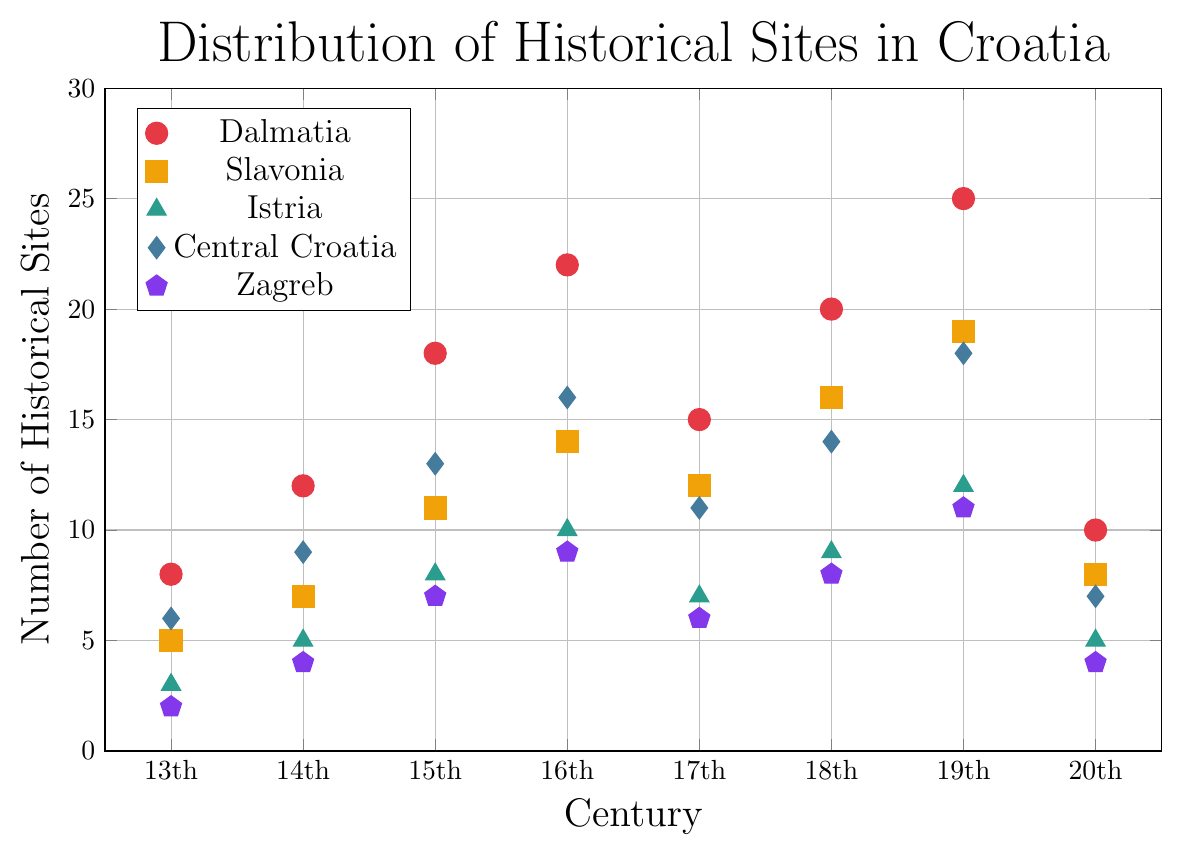Which region has the highest number of historical sites in the 16th century? Locate the data points for the 16th century and compare the values for each region. Dalmatia has 22 sites, which is the highest.
Answer: Dalmatia Which century had the highest average number of historical sites across all regions? First, calculate the average number of sites for each century by summing the number of sites for all regions within that century and then dividing by 5 (since there are five regions). Compare these averages. The 19th century has the highest average.
Answer: 19th century How did the number of historical sites in Zagreb change from the 13th century to the 19th century? Observe the values for Zagreb in both the 13th and 19th centuries. The number of sites increased from 2 in the 13th century to 11 in the 19th century.
Answer: Increased In which century did Central Croatia have its lowest number of historical sites? Identify the data points for Central Croatia across the centuries and determine the lowest value. The lowest value is 6 in the 13th century.
Answer: 13th century Which region consistently had the highest number of historical sites across all centuries? Compare the values for each region across all centuries. Dalmatia always has the highest number of sites across all centuries.
Answer: Dalmatia What is the total number of historical sites for Istria from the 13th to the 20th century? Sum up the number of sites for Istria across all centuries: 3 (13th) + 5 (14th) + 8 (15th) + 10 (16th) + 7 (17th) + 9 (18th) + 12 (19th) + 5 (20th) = 59.
Answer: 59 Which century saw the biggest increase in the number of historical sites for Dalmatia compared to the previous century? Calculate the difference in the number of sites for Dalmatia between consecutive centuries and compare. The biggest increase is from the 15th (18 sites) to the 16th century (22 sites), with an increase of 4 sites.
Answer: 16th century How does the number of historical sites in Slavonia in the 14th century compare to that in Central Croatia in the same century? Check the values for Slavonia and Central Croatia in the 14th century. Slavonia has 7 sites, while Central Croatia has 9. Central Croatia has more sites.
Answer: Central Croatia has more What is the median number of historical sites for Central Croatia across all centuries? List the number of sites for Central Croatia: 6 (13th), 9 (14th), 13 (15th), 16 (16th), 11 (17th), 14 (18th), 18 (19th), 7 (20th). Sort: 6, 7, 9, 11, 13, 14, 16, 18. The median is the average of 11 and 13, which is 12.
Answer: 12 Which region had the least increase in the number of historical sites from the 15th to the 16th century? Calculate the difference between the 15th and 16th-century values for each region: Dalmatia (22-18=4), Slavonia (14-11=3), Istria (10-8=2), Central Croatia (16-13=3), Zagreb (9-7=2). Istria and Zagreb had the least increase, both with 2.
Answer: Istria/Zagreb 